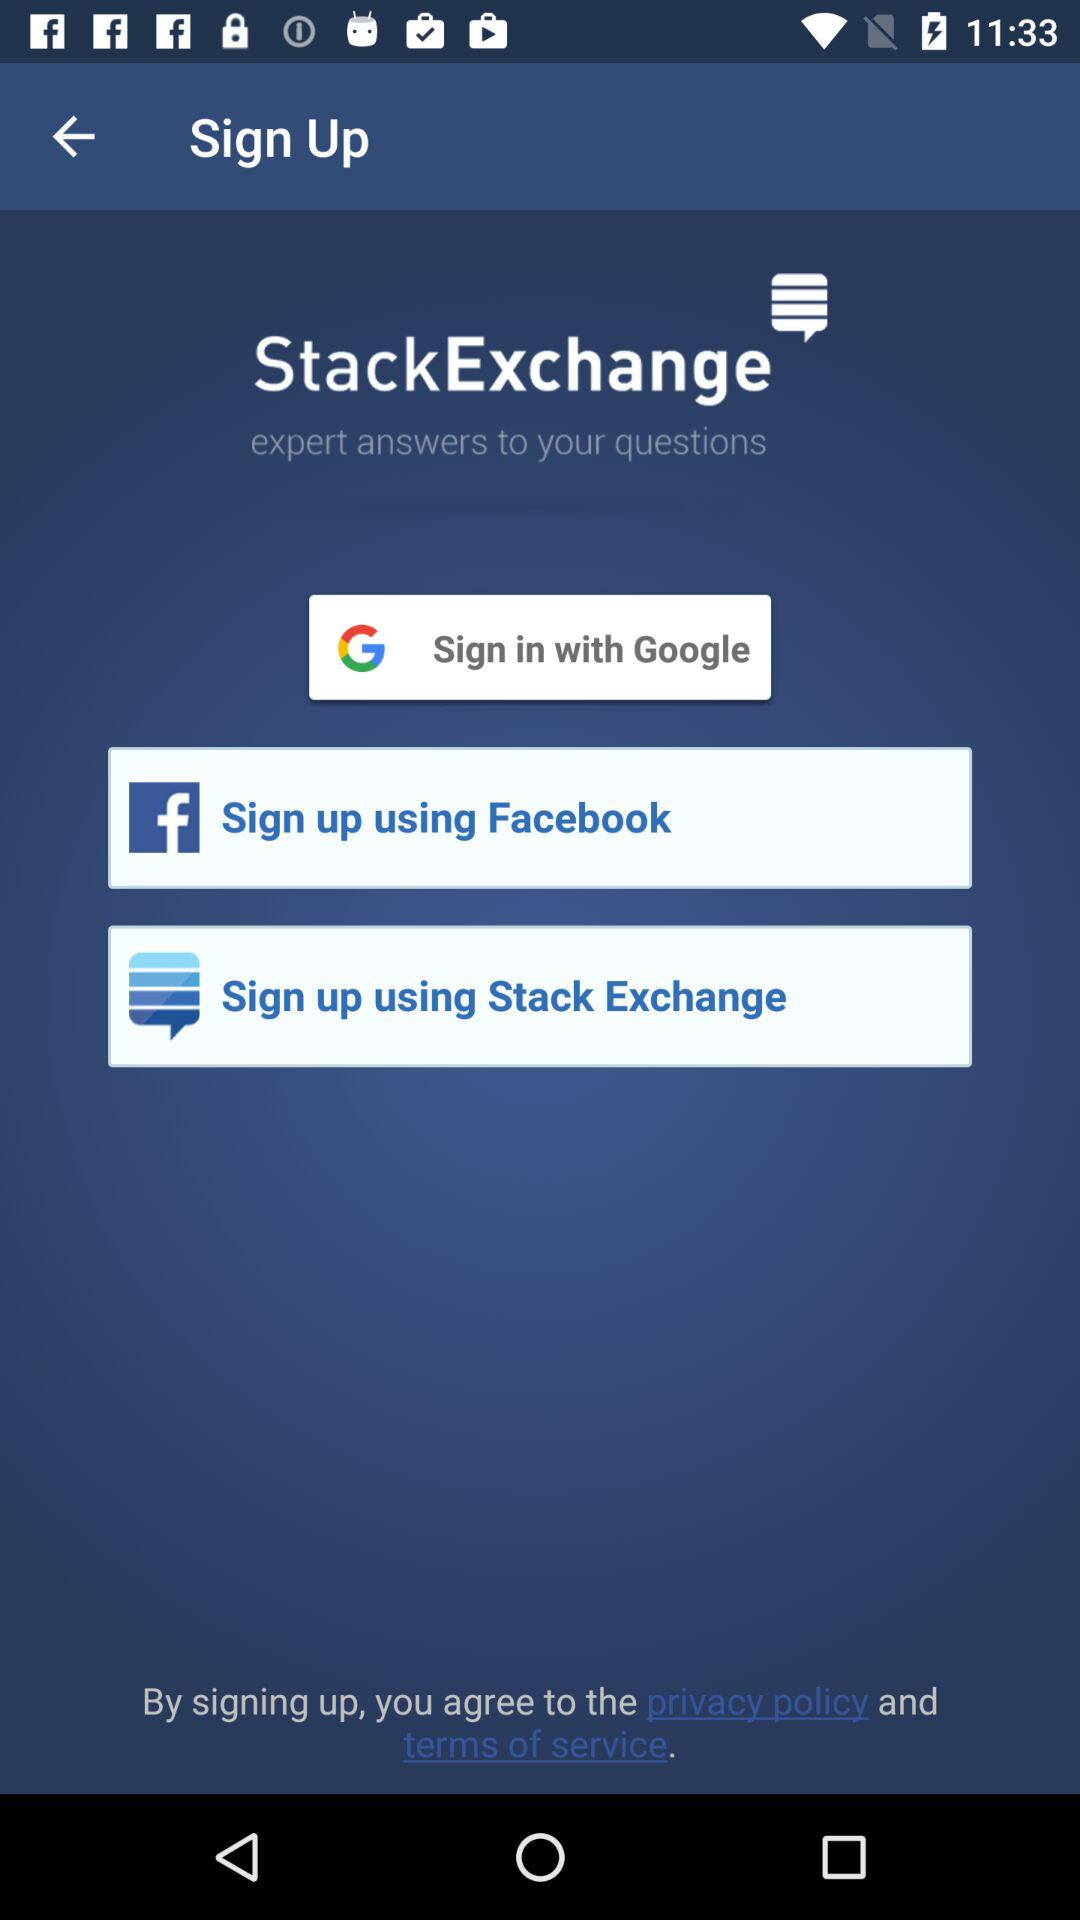Which options are given for signing up? The options that are given for signing up are "Google", "Facebook" and "Stack Exchange". 